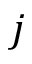<formula> <loc_0><loc_0><loc_500><loc_500>j</formula> 